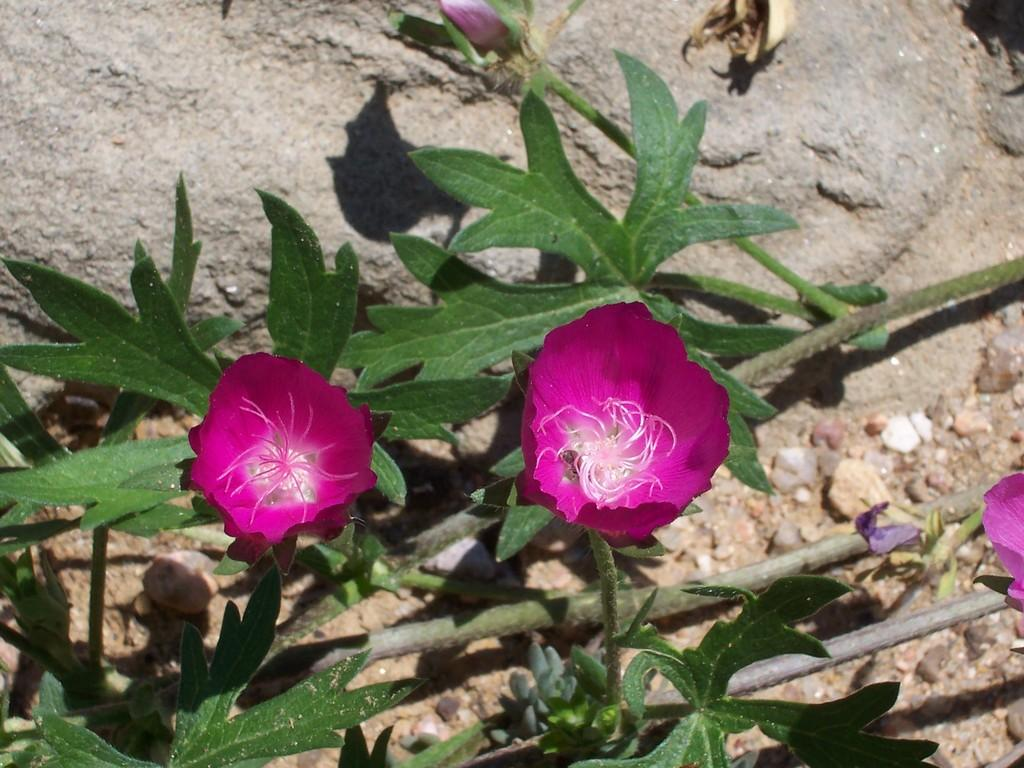What is located in the center of the image? There are flowers and plants in the center of the image. Can you describe the plants in the image? The plants in the image are flowers. What can be seen in the background of the image? There are stones visible in the background of the image. How many irons are present in the image? There are no irons present in the image. What does the son of the person who took the image think about the flowers? The provided facts do not mention any person taking the image or their son, so we cannot answer this question. 